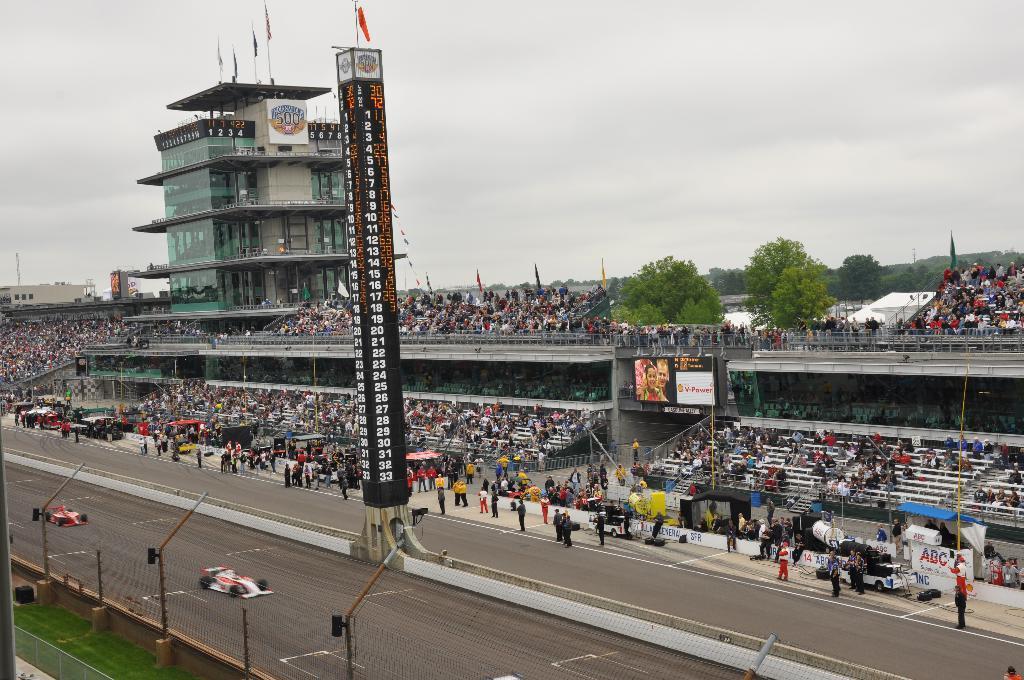Can you describe this image briefly? This picture might be taken inside a stadium. In this image, on the right side, we can see two sports cars are moving on the road. In this image, in the middle, we can see a pole. On the right side, we can see a group of people, tents, trees, flags, building, glass window. At the top, we can see a sky which is cloudy, at the bottom, we can see a road. 